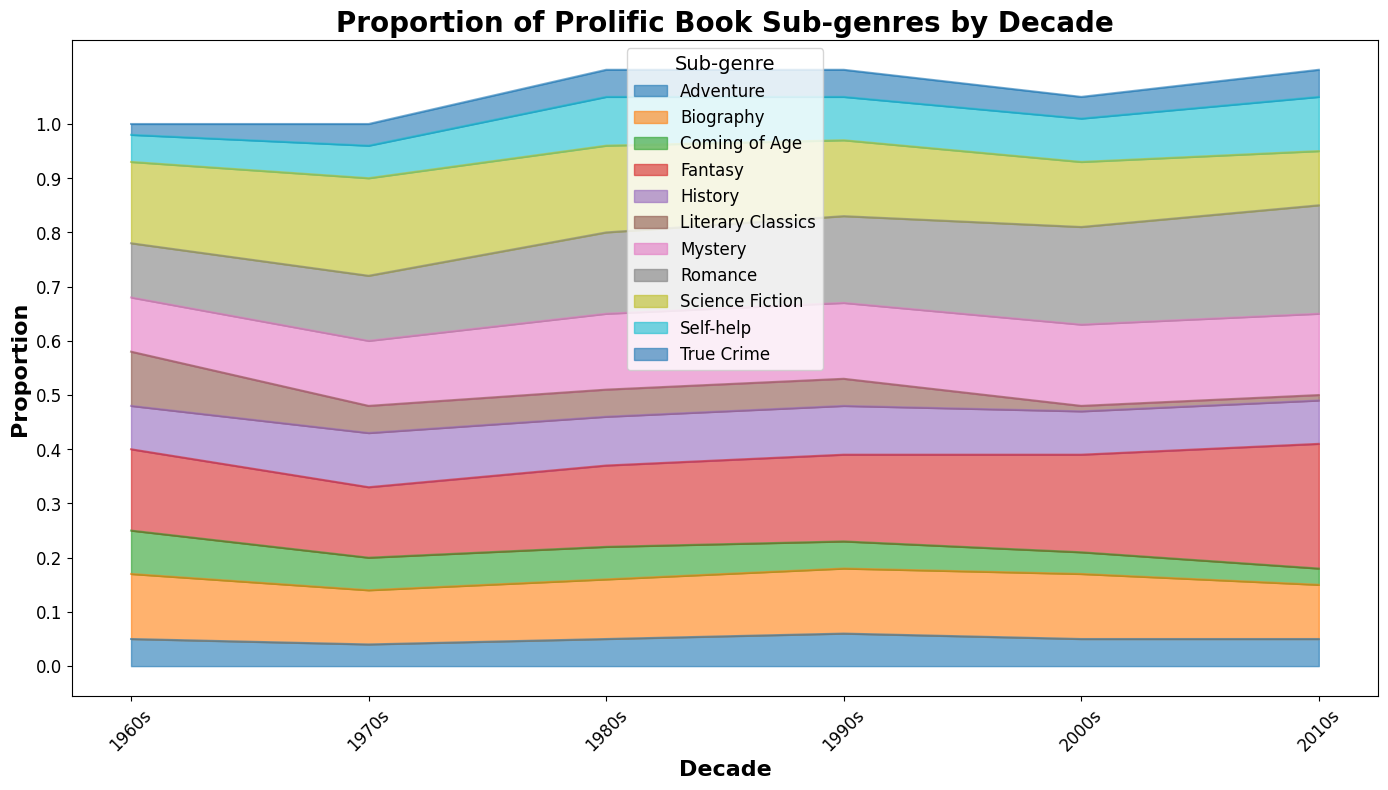Which sub-genre had the highest proportion in the 2010s? Looking at the area chart, the Romance sub-genre in the 2010s appears to have the largest area, indicating the highest proportion.
Answer: Romance Which sub-genre increased the most in proportion from the 1960s to the 2010s? Observing the plot, the Romance sub-genre shows a substantial increase from the 1960s (0.10) to the 2010s (0.20), doubling in proportion.
Answer: Romance Between Science Fiction and Fantasy sub-genres, which one dominated more through the decades? By examining the overall area occupied by each sub-genre across the decades, Science Fiction has a more consistently larger area than Fantasy, indicating it dominated more.
Answer: Science Fiction Which decade had the smallest combined proportion for the sub-genres Adventure and Coming of Age? Reviewing the height of areas for Adventure and Coming of Age sub-genres across decades, the 2000s show the smallest combined proportion.
Answer: 2000s What was the trend in the proportion of Mystery sub-genre from the 1960s to the 2010s? Observing the Mystery sub-genre, the proportion increases from the 1960s (0.10) to the 1970s (0.12) and further increases, peaking in the 2000s (0.15), then remains stable in the 2010s (0.15).
Answer: Increasing Which two sub-genres were consistently present in each decade from the 1960s to the 2010s? The consistently present sub-genres through each decade can be identified from the chart as Science Fiction and Romance, which appear in all periods.
Answer: Science Fiction, Romance How did the proportion of the Self-help sub-genre change from the 1960s to the 2010s? By examining the area charts, Self-help starts at 0.05 in the 1960s, increases slightly in the 1970s (0.06), peaks in the 1980s (0.09) and remains steady in the 2000s and 2010s (0.08 and 0.10).
Answer: Steady increase Which sub-genre had a notable decline in proportion from the 1980s to the 2000s? The Literary Classics sub-genre shows a notable decline in proportion, from 0.05 in the 1980s to only 0.01 in the 2000s.
Answer: Literary Classics 